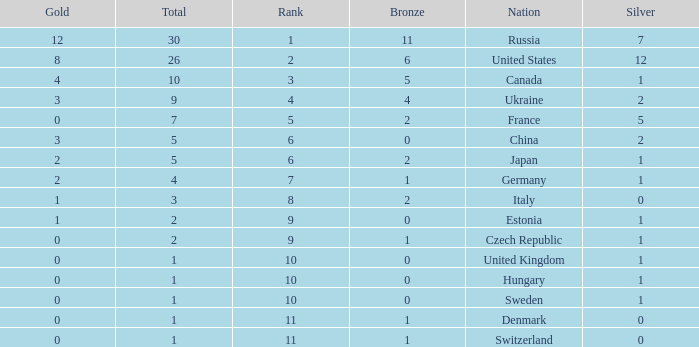What is the largest silver with Gold larger than 4, a Nation of united states, and a Total larger than 26? None. 